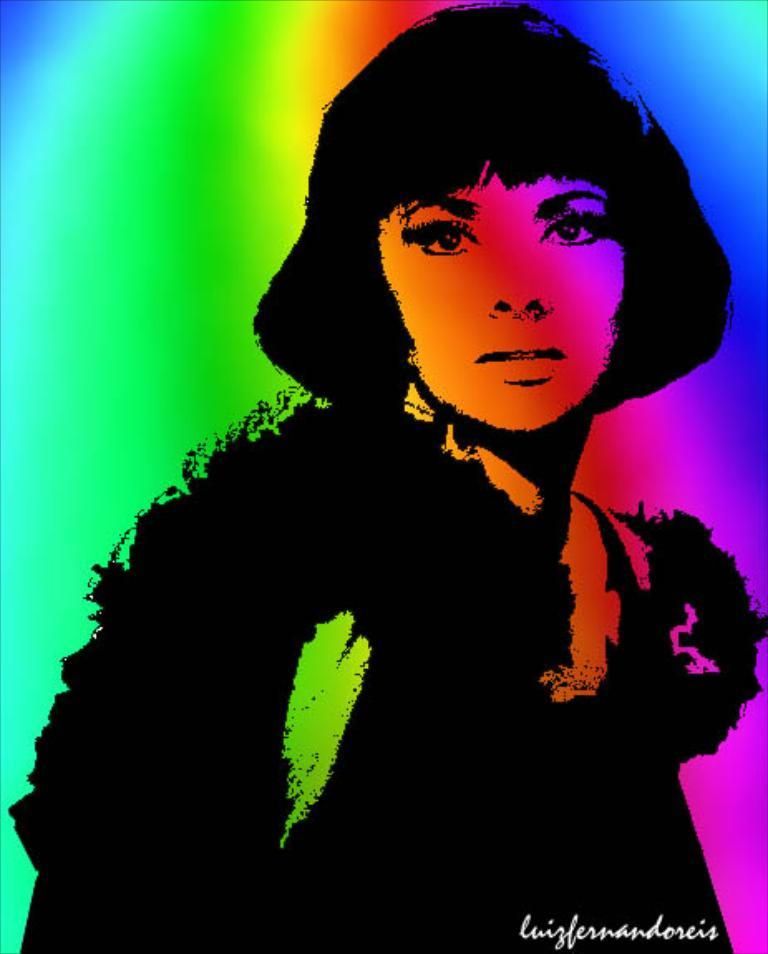What type of image is depicted in the picture? There is an animated picture of a woman in the image. Is there any text present in the image? Yes, there is text at the bottom of the image. Where is the sofa located in the image? There is no sofa present in the image. What type of toothpaste is the woman using in the image? There is no toothpaste or any indication of personal care products in the image. 